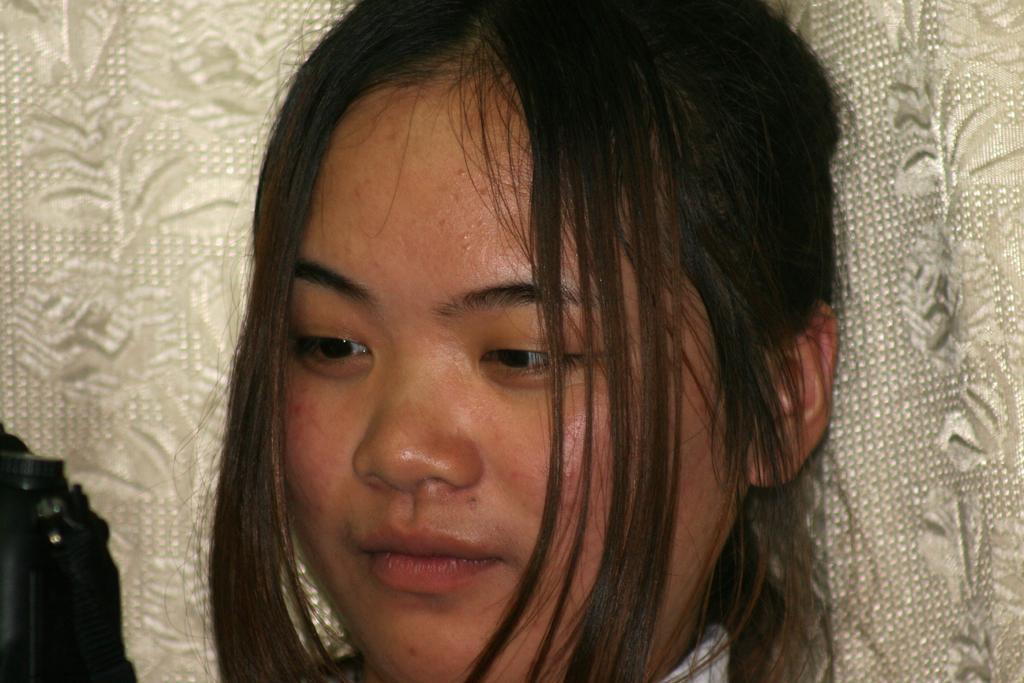Could you give a brief overview of what you see in this image? In this image I can see the person's face and I can see white color background. 